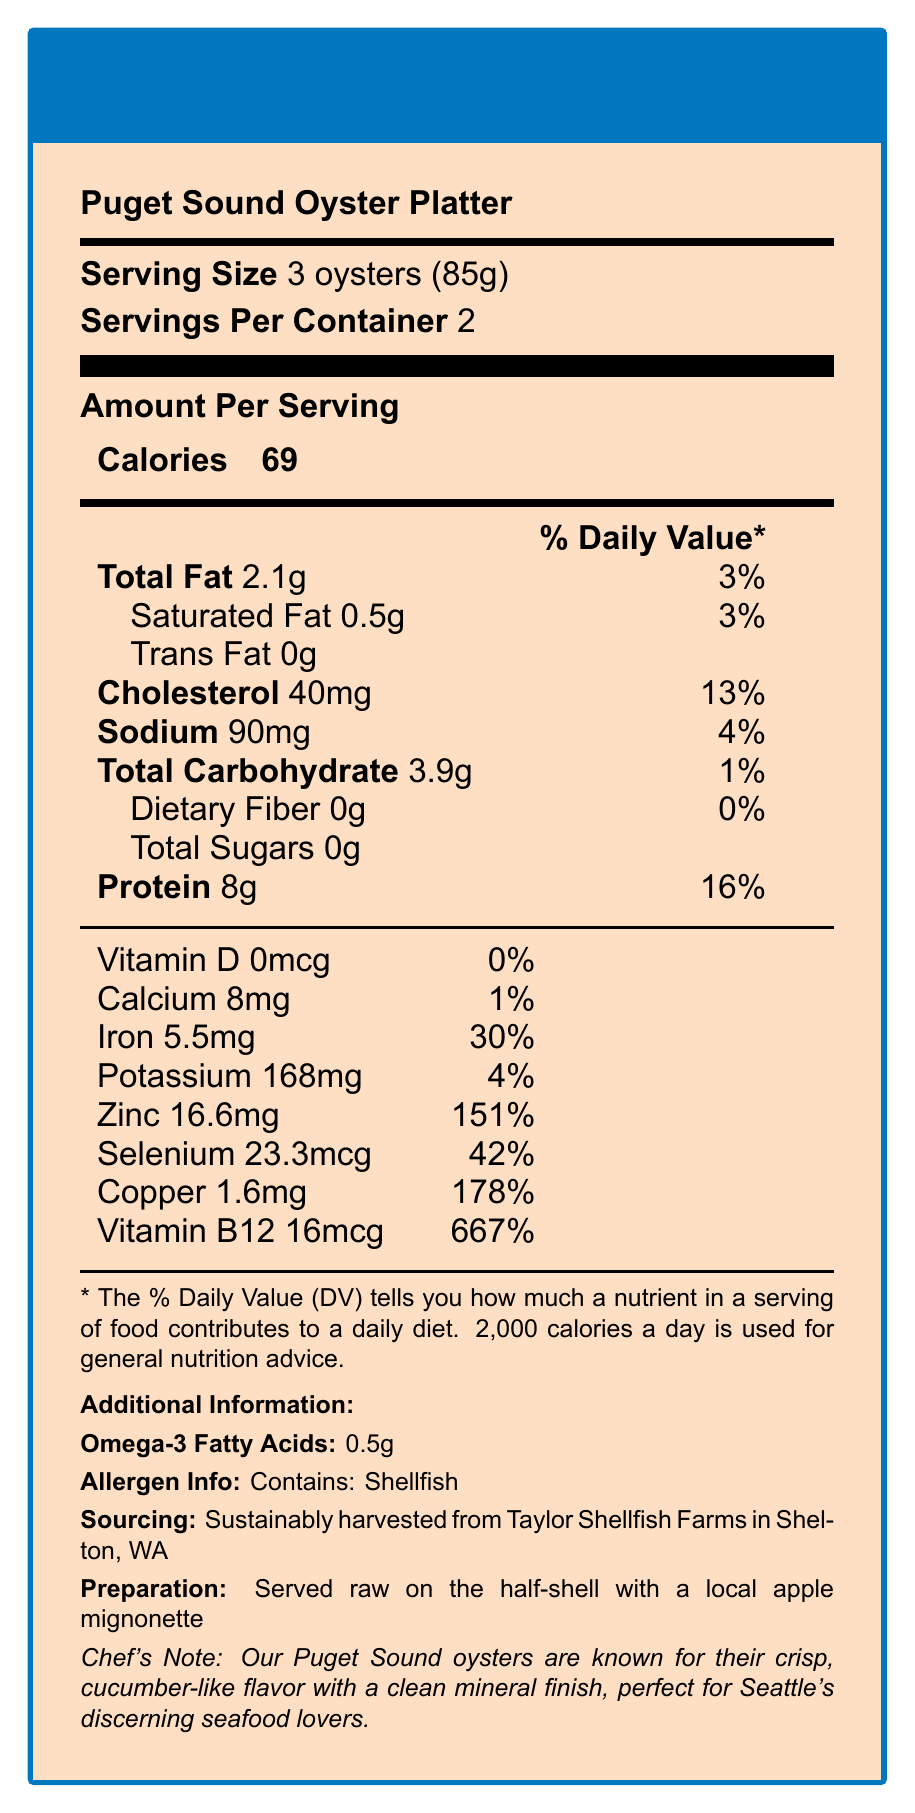what is the serving size? The document states that the serving size is 3 oysters (85g).
Answer: 3 oysters (85g) how many servings are in the container? The document mentions that there are 2 servings per container.
Answer: 2 what is the calorie count per serving? The document lists 69 calories per serving.
Answer: 69 calories what is the amount of cholesterol per serving? The document states that there are 40mg of cholesterol per serving.
Answer: 40mg what is the % daily value of iron per serving? The document shows that the % daily value of iron per serving is 30%.
Answer: 30% how much potassium is in one serving? The document indicates that there is 168mg of potassium per serving.
Answer: 168mg what is the primary allergen in this dish? The allergen info section states that the dish contains shellfish.
Answer: Shellfish how is the dish prepared? The document states in the preparation section that the dish is served raw on the half-shell with a local apple mignonette.
Answer: Served raw on the half-shell with a local apple mignonette what are the sources of this dish? The document mentions that the oysters are sustainably harvested from Taylor Shellfish Farms in Shelton, WA.
Answer: Sustainably harvested from Taylor Shellfish Farms in Shelton, WA how much Vitamin B12 is in one serving? The document states that one serving contains 16mcg of Vitamin B12.
Answer: 16mcg how much omega-3 fatty acids are in each serving? The document lists that each serving contains 0.5g of omega-3 fatty acids.
Answer: 0.5g which mineral has the highest % daily value per serving? A. Zinc B. Copper C. Iron The document lists copper with a % daily value of 178%, the highest among the minerals listed.
Answer: B. Copper which of the following is NOT a feature of the Puget Sound Oyster Platter? A. Grown in Seattle B. Contains shellfish C. Served raw The document specifies that the oysters are harvested from Taylor Shellfish Farms in Shelton, WA, not grown in Seattle.
Answer: A. Grown in Seattle does this dish contain trans fat? The document states that there is 0g of trans fat per serving.
Answer: No is there any dietary fiber in this dish? The document lists 0g of dietary fiber per serving.
Answer: No describe the Nutrition Facts of the Puget Sound Oyster Platter. This summary describes the various nutritional aspects, allergen information, sourcing, and preparation method of the Puget Sound Oyster Platter as outlined in the document.
Answer: The Puget Sound Oyster Platter contains 69 calories per serving, with each serving consisting of 3 oysters (85g). It has 2.1g of total fat, 0.5g of saturated fat, 40mg of cholesterol, 90mg of sodium, 3.9g of total carbohydrates, and 8g of protein. It also includes significant minerals such as 5.5mg of iron, 16.6mg of zinc, 23.3mcg of selenium, 1.6mg of copper, and 16mcg of Vitamin B12. The dish is allergenic as it contains shellfish and is sustainably harvested from Taylor Shellfish Farms in Shelton, WA. It is served raw with a local apple mignonette. what is the Vitamin A content in this dish? The document does not provide any information about the Vitamin A content.
Answer: Not enough information 